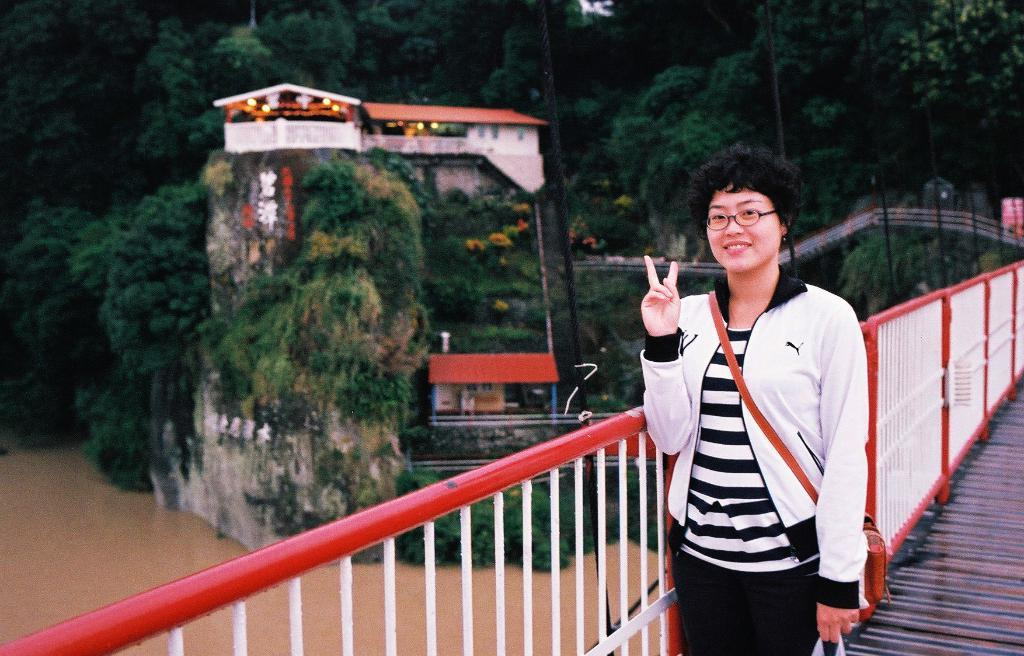Who is the main subject in the image? There is a woman standing in the front of the image. What is the woman doing in the image? The woman is smiling. What can be seen near the woman in the image? There is a railing in the image. What is visible in the background of the image? Water, trees, and houses are visible in the background of the image. What type of dinosaurs can be seen swimming in the water in the background of the image? There are no dinosaurs present in the image; only water, trees, and houses are visible in the background. 